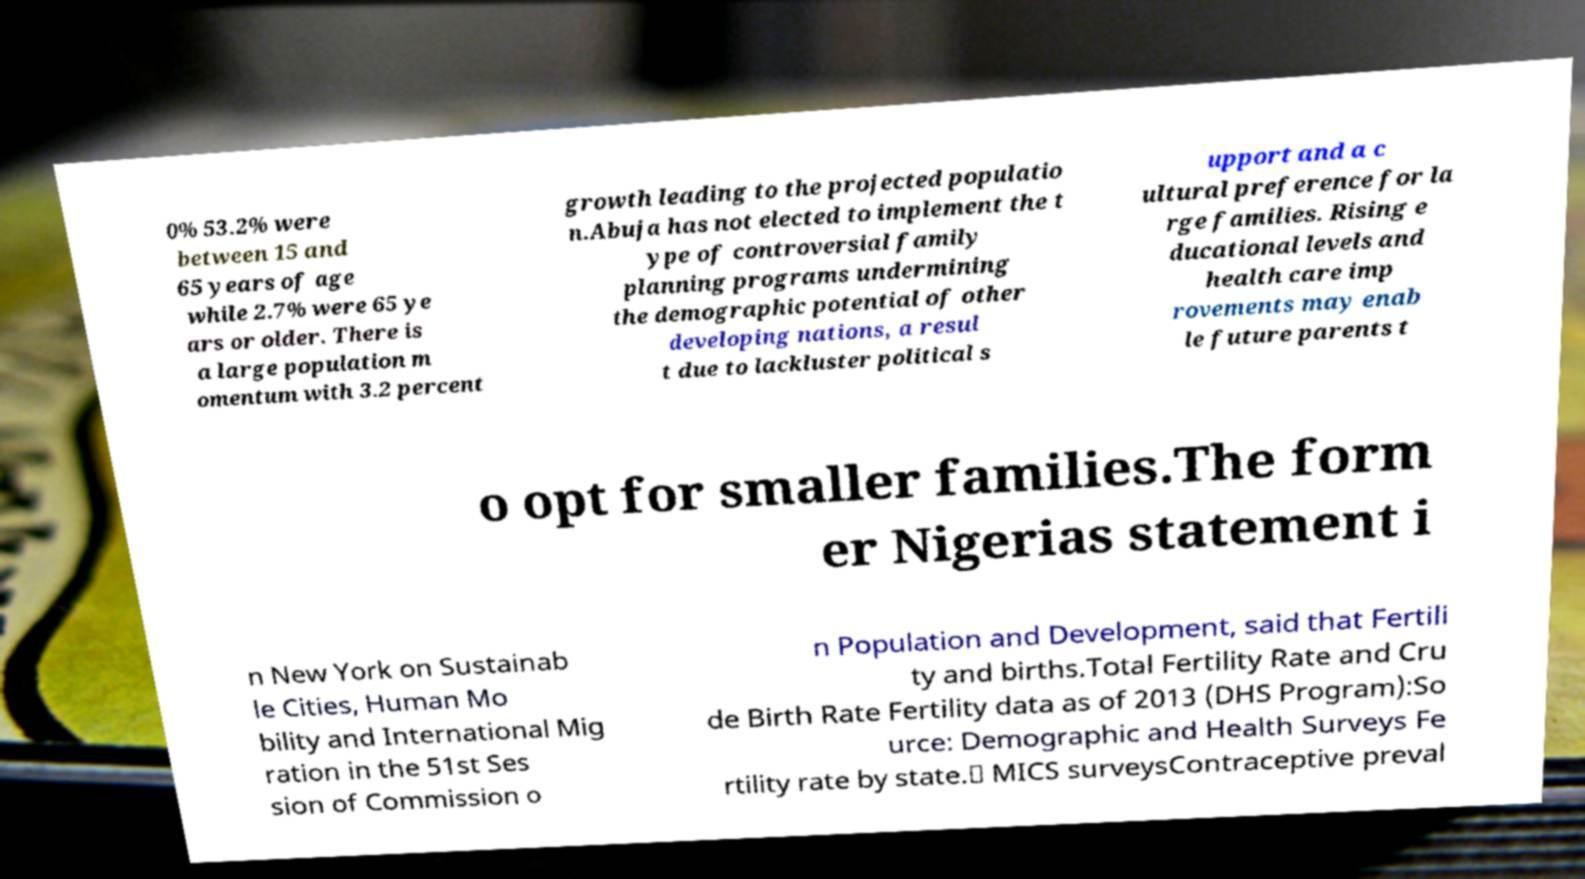Can you accurately transcribe the text from the provided image for me? 0% 53.2% were between 15 and 65 years of age while 2.7% were 65 ye ars or older. There is a large population m omentum with 3.2 percent growth leading to the projected populatio n.Abuja has not elected to implement the t ype of controversial family planning programs undermining the demographic potential of other developing nations, a resul t due to lackluster political s upport and a c ultural preference for la rge families. Rising e ducational levels and health care imp rovements may enab le future parents t o opt for smaller families.The form er Nigerias statement i n New York on Sustainab le Cities, Human Mo bility and International Mig ration in the 51st Ses sion of Commission o n Population and Development, said that Fertili ty and births.Total Fertility Rate and Cru de Birth Rate Fertility data as of 2013 (DHS Program):So urce: Demographic and Health Surveys Fe rtility rate by state.∗ MICS surveysContraceptive preval 